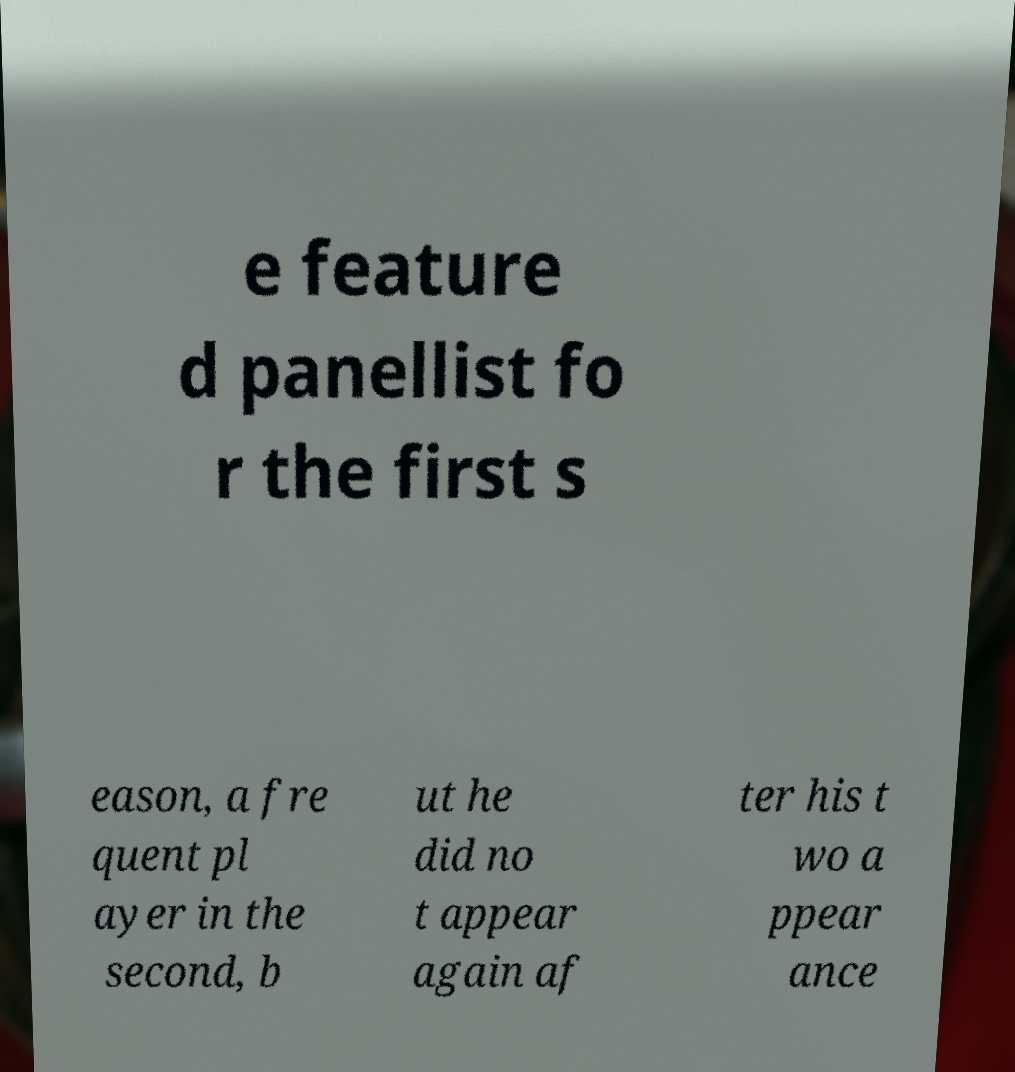There's text embedded in this image that I need extracted. Can you transcribe it verbatim? e feature d panellist fo r the first s eason, a fre quent pl ayer in the second, b ut he did no t appear again af ter his t wo a ppear ance 